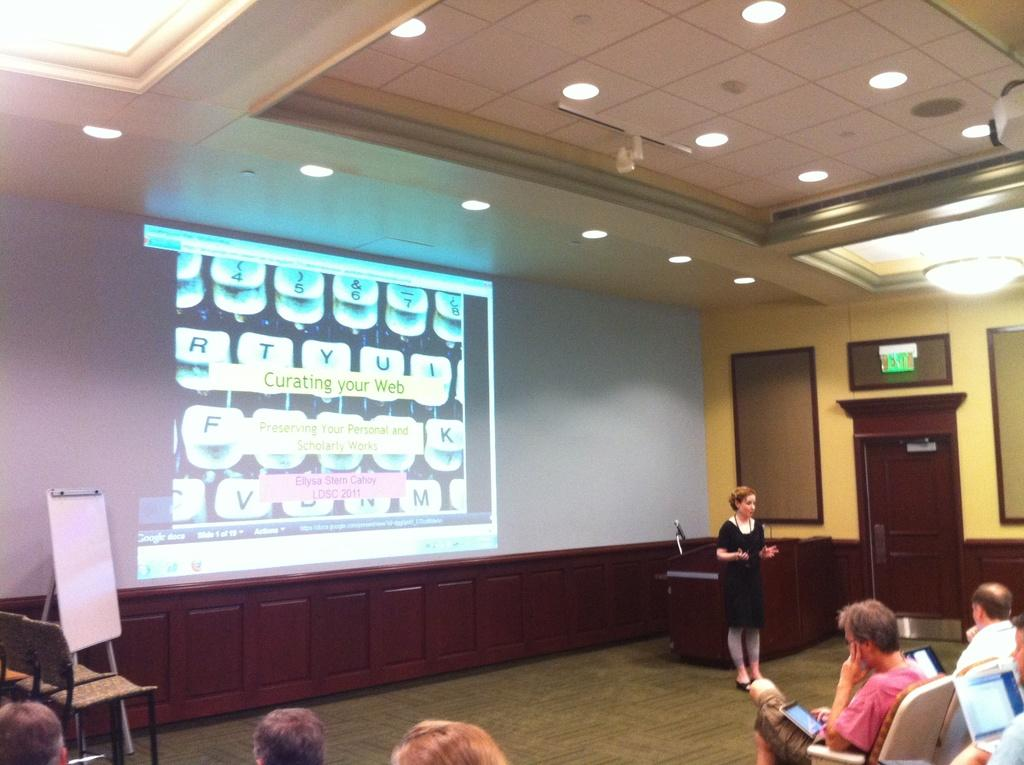Provide a one-sentence caption for the provided image. a conference room and a screen in front saying Curating your Web Preserving your personal and scholarly works Ellysa Stern Cahoy LDSC 2011. 